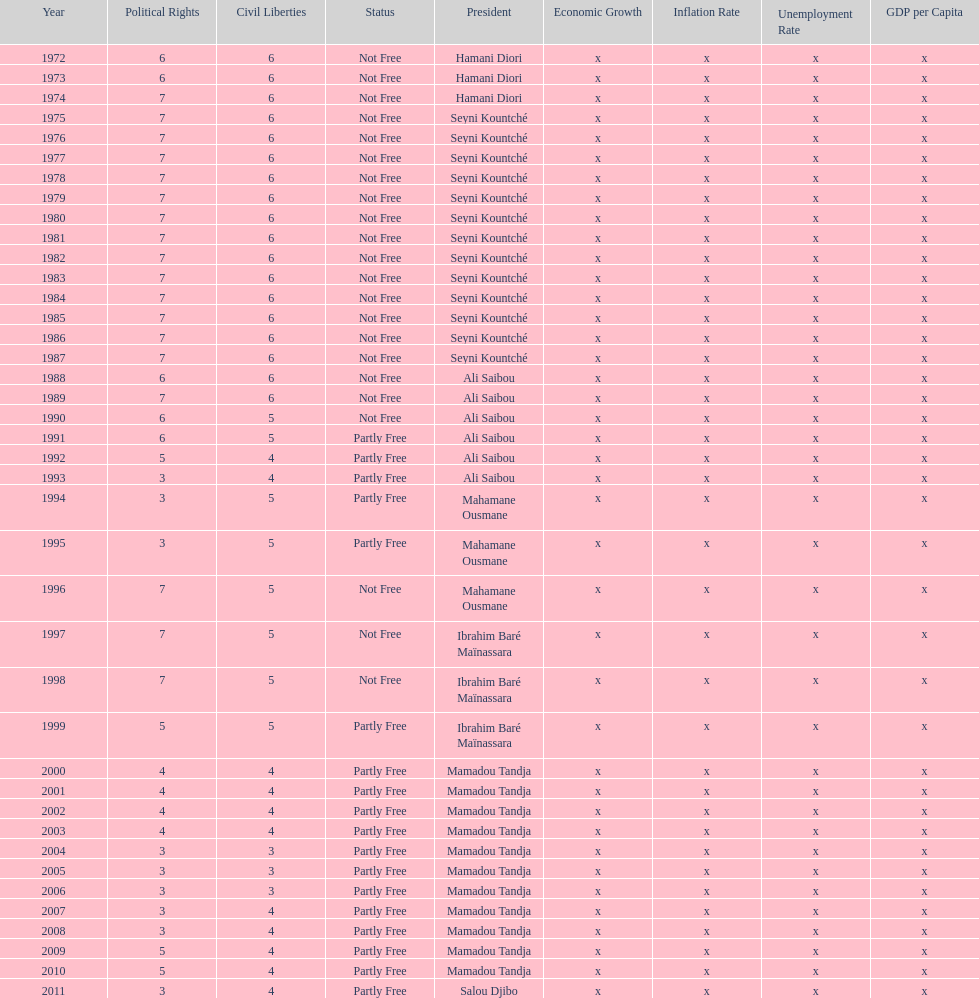Who is the next president listed after hamani diori in the year 1974? Seyni Kountché. 